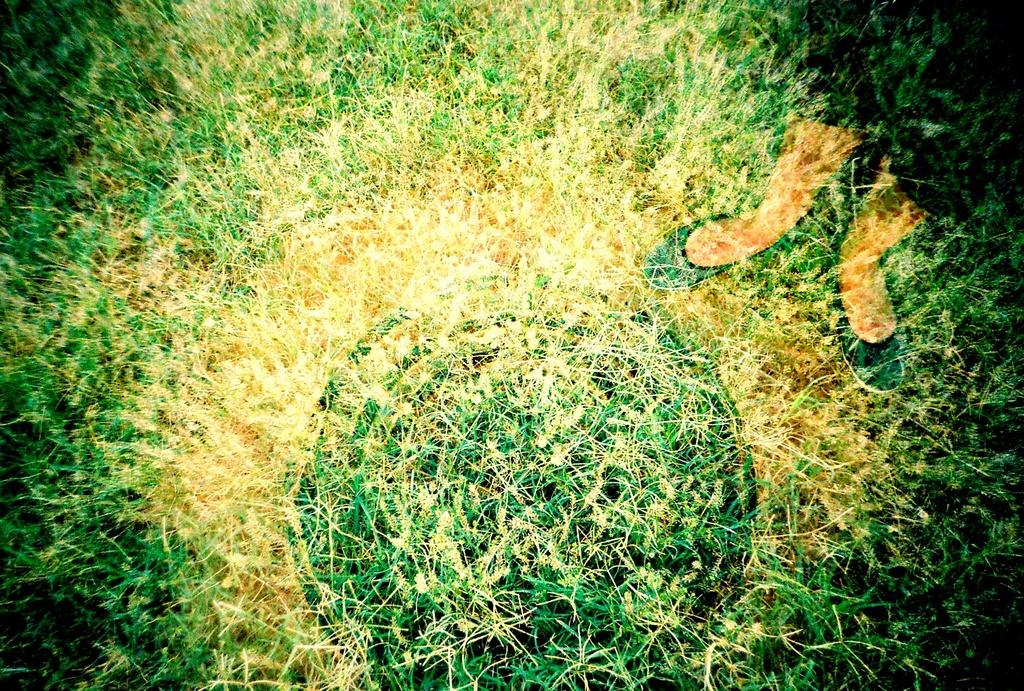What type of vegetation is in the foreground of the image? There is grass in the foreground of the image. Can you describe any human presence in the image? Yes, there are legs of a person visible on the right side of the image. What type of sock is the person wearing on their left foot in the image? There is no information about the person's socks in the image. What instrument is the person playing in the image? There is no instrument present in the image. 